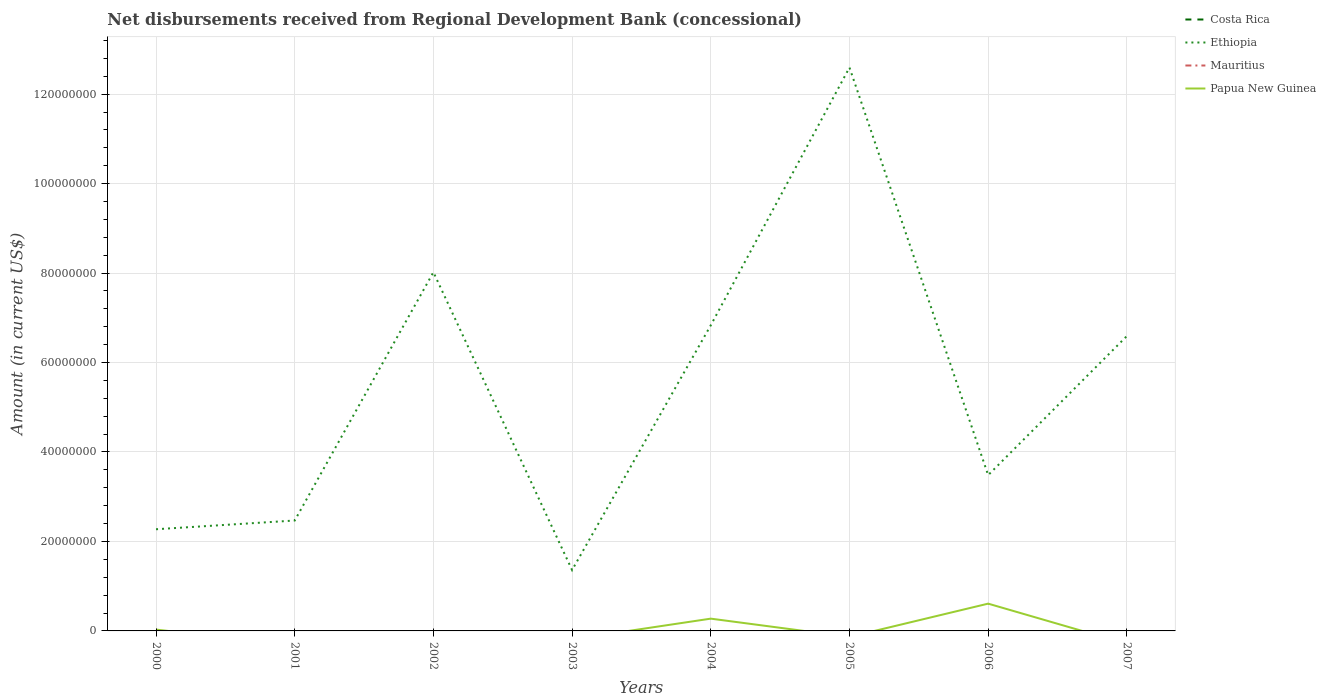Does the line corresponding to Costa Rica intersect with the line corresponding to Papua New Guinea?
Make the answer very short. No. Is the number of lines equal to the number of legend labels?
Your answer should be very brief. No. Across all years, what is the maximum amount of disbursements received from Regional Development Bank in Mauritius?
Offer a terse response. 0. What is the total amount of disbursements received from Regional Development Bank in Ethiopia in the graph?
Your response must be concise. -1.12e+08. What is the difference between the highest and the second highest amount of disbursements received from Regional Development Bank in Papua New Guinea?
Keep it short and to the point. 6.10e+06. Is the amount of disbursements received from Regional Development Bank in Papua New Guinea strictly greater than the amount of disbursements received from Regional Development Bank in Mauritius over the years?
Ensure brevity in your answer.  No. What is the difference between two consecutive major ticks on the Y-axis?
Offer a terse response. 2.00e+07. Are the values on the major ticks of Y-axis written in scientific E-notation?
Ensure brevity in your answer.  No. Where does the legend appear in the graph?
Offer a very short reply. Top right. How many legend labels are there?
Give a very brief answer. 4. What is the title of the graph?
Ensure brevity in your answer.  Net disbursements received from Regional Development Bank (concessional). Does "OECD members" appear as one of the legend labels in the graph?
Offer a terse response. No. What is the label or title of the Y-axis?
Ensure brevity in your answer.  Amount (in current US$). What is the Amount (in current US$) of Costa Rica in 2000?
Offer a terse response. 0. What is the Amount (in current US$) of Ethiopia in 2000?
Offer a very short reply. 2.27e+07. What is the Amount (in current US$) of Mauritius in 2000?
Offer a terse response. 0. What is the Amount (in current US$) in Papua New Guinea in 2000?
Keep it short and to the point. 2.99e+05. What is the Amount (in current US$) in Ethiopia in 2001?
Your answer should be very brief. 2.47e+07. What is the Amount (in current US$) in Papua New Guinea in 2001?
Give a very brief answer. 0. What is the Amount (in current US$) in Costa Rica in 2002?
Keep it short and to the point. 0. What is the Amount (in current US$) in Ethiopia in 2002?
Provide a short and direct response. 8.02e+07. What is the Amount (in current US$) of Ethiopia in 2003?
Ensure brevity in your answer.  1.36e+07. What is the Amount (in current US$) of Papua New Guinea in 2003?
Your response must be concise. 0. What is the Amount (in current US$) of Costa Rica in 2004?
Offer a very short reply. 0. What is the Amount (in current US$) of Ethiopia in 2004?
Offer a very short reply. 6.83e+07. What is the Amount (in current US$) of Papua New Guinea in 2004?
Give a very brief answer. 2.74e+06. What is the Amount (in current US$) of Ethiopia in 2005?
Give a very brief answer. 1.26e+08. What is the Amount (in current US$) in Mauritius in 2005?
Provide a short and direct response. 0. What is the Amount (in current US$) of Ethiopia in 2006?
Make the answer very short. 3.48e+07. What is the Amount (in current US$) in Papua New Guinea in 2006?
Provide a short and direct response. 6.10e+06. What is the Amount (in current US$) in Ethiopia in 2007?
Your answer should be compact. 6.59e+07. What is the Amount (in current US$) of Papua New Guinea in 2007?
Your response must be concise. 0. Across all years, what is the maximum Amount (in current US$) in Ethiopia?
Your response must be concise. 1.26e+08. Across all years, what is the maximum Amount (in current US$) of Papua New Guinea?
Offer a terse response. 6.10e+06. Across all years, what is the minimum Amount (in current US$) of Ethiopia?
Give a very brief answer. 1.36e+07. What is the total Amount (in current US$) in Costa Rica in the graph?
Offer a very short reply. 0. What is the total Amount (in current US$) in Ethiopia in the graph?
Offer a very short reply. 4.36e+08. What is the total Amount (in current US$) of Papua New Guinea in the graph?
Provide a succinct answer. 9.14e+06. What is the difference between the Amount (in current US$) of Ethiopia in 2000 and that in 2001?
Your answer should be compact. -1.95e+06. What is the difference between the Amount (in current US$) of Ethiopia in 2000 and that in 2002?
Offer a very short reply. -5.75e+07. What is the difference between the Amount (in current US$) in Ethiopia in 2000 and that in 2003?
Keep it short and to the point. 9.12e+06. What is the difference between the Amount (in current US$) of Ethiopia in 2000 and that in 2004?
Your answer should be very brief. -4.56e+07. What is the difference between the Amount (in current US$) in Papua New Guinea in 2000 and that in 2004?
Offer a terse response. -2.45e+06. What is the difference between the Amount (in current US$) in Ethiopia in 2000 and that in 2005?
Your answer should be very brief. -1.03e+08. What is the difference between the Amount (in current US$) in Ethiopia in 2000 and that in 2006?
Offer a very short reply. -1.21e+07. What is the difference between the Amount (in current US$) of Papua New Guinea in 2000 and that in 2006?
Your answer should be very brief. -5.80e+06. What is the difference between the Amount (in current US$) of Ethiopia in 2000 and that in 2007?
Give a very brief answer. -4.32e+07. What is the difference between the Amount (in current US$) of Ethiopia in 2001 and that in 2002?
Your response must be concise. -5.55e+07. What is the difference between the Amount (in current US$) in Ethiopia in 2001 and that in 2003?
Provide a succinct answer. 1.11e+07. What is the difference between the Amount (in current US$) of Ethiopia in 2001 and that in 2004?
Your answer should be compact. -4.36e+07. What is the difference between the Amount (in current US$) of Ethiopia in 2001 and that in 2005?
Offer a very short reply. -1.01e+08. What is the difference between the Amount (in current US$) of Ethiopia in 2001 and that in 2006?
Ensure brevity in your answer.  -1.01e+07. What is the difference between the Amount (in current US$) of Ethiopia in 2001 and that in 2007?
Your answer should be compact. -4.12e+07. What is the difference between the Amount (in current US$) of Ethiopia in 2002 and that in 2003?
Your response must be concise. 6.66e+07. What is the difference between the Amount (in current US$) in Ethiopia in 2002 and that in 2004?
Offer a terse response. 1.19e+07. What is the difference between the Amount (in current US$) of Ethiopia in 2002 and that in 2005?
Offer a very short reply. -4.58e+07. What is the difference between the Amount (in current US$) in Ethiopia in 2002 and that in 2006?
Make the answer very short. 4.54e+07. What is the difference between the Amount (in current US$) of Ethiopia in 2002 and that in 2007?
Give a very brief answer. 1.43e+07. What is the difference between the Amount (in current US$) of Ethiopia in 2003 and that in 2004?
Offer a very short reply. -5.47e+07. What is the difference between the Amount (in current US$) of Ethiopia in 2003 and that in 2005?
Provide a short and direct response. -1.12e+08. What is the difference between the Amount (in current US$) in Ethiopia in 2003 and that in 2006?
Make the answer very short. -2.12e+07. What is the difference between the Amount (in current US$) of Ethiopia in 2003 and that in 2007?
Your answer should be compact. -5.23e+07. What is the difference between the Amount (in current US$) of Ethiopia in 2004 and that in 2005?
Offer a terse response. -5.76e+07. What is the difference between the Amount (in current US$) of Ethiopia in 2004 and that in 2006?
Keep it short and to the point. 3.35e+07. What is the difference between the Amount (in current US$) of Papua New Guinea in 2004 and that in 2006?
Give a very brief answer. -3.35e+06. What is the difference between the Amount (in current US$) in Ethiopia in 2004 and that in 2007?
Your response must be concise. 2.41e+06. What is the difference between the Amount (in current US$) in Ethiopia in 2005 and that in 2006?
Give a very brief answer. 9.11e+07. What is the difference between the Amount (in current US$) in Ethiopia in 2005 and that in 2007?
Make the answer very short. 6.00e+07. What is the difference between the Amount (in current US$) of Ethiopia in 2006 and that in 2007?
Ensure brevity in your answer.  -3.11e+07. What is the difference between the Amount (in current US$) in Ethiopia in 2000 and the Amount (in current US$) in Papua New Guinea in 2004?
Your response must be concise. 2.00e+07. What is the difference between the Amount (in current US$) of Ethiopia in 2000 and the Amount (in current US$) of Papua New Guinea in 2006?
Provide a short and direct response. 1.66e+07. What is the difference between the Amount (in current US$) of Ethiopia in 2001 and the Amount (in current US$) of Papua New Guinea in 2004?
Your response must be concise. 2.19e+07. What is the difference between the Amount (in current US$) of Ethiopia in 2001 and the Amount (in current US$) of Papua New Guinea in 2006?
Make the answer very short. 1.86e+07. What is the difference between the Amount (in current US$) of Ethiopia in 2002 and the Amount (in current US$) of Papua New Guinea in 2004?
Give a very brief answer. 7.74e+07. What is the difference between the Amount (in current US$) in Ethiopia in 2002 and the Amount (in current US$) in Papua New Guinea in 2006?
Make the answer very short. 7.41e+07. What is the difference between the Amount (in current US$) in Ethiopia in 2003 and the Amount (in current US$) in Papua New Guinea in 2004?
Give a very brief answer. 1.09e+07. What is the difference between the Amount (in current US$) in Ethiopia in 2003 and the Amount (in current US$) in Papua New Guinea in 2006?
Offer a very short reply. 7.51e+06. What is the difference between the Amount (in current US$) of Ethiopia in 2004 and the Amount (in current US$) of Papua New Guinea in 2006?
Ensure brevity in your answer.  6.22e+07. What is the difference between the Amount (in current US$) in Ethiopia in 2005 and the Amount (in current US$) in Papua New Guinea in 2006?
Your answer should be compact. 1.20e+08. What is the average Amount (in current US$) of Ethiopia per year?
Your answer should be very brief. 5.45e+07. What is the average Amount (in current US$) of Papua New Guinea per year?
Offer a very short reply. 1.14e+06. In the year 2000, what is the difference between the Amount (in current US$) in Ethiopia and Amount (in current US$) in Papua New Guinea?
Make the answer very short. 2.24e+07. In the year 2004, what is the difference between the Amount (in current US$) in Ethiopia and Amount (in current US$) in Papua New Guinea?
Provide a succinct answer. 6.56e+07. In the year 2006, what is the difference between the Amount (in current US$) in Ethiopia and Amount (in current US$) in Papua New Guinea?
Your response must be concise. 2.87e+07. What is the ratio of the Amount (in current US$) in Ethiopia in 2000 to that in 2001?
Your response must be concise. 0.92. What is the ratio of the Amount (in current US$) of Ethiopia in 2000 to that in 2002?
Provide a short and direct response. 0.28. What is the ratio of the Amount (in current US$) in Ethiopia in 2000 to that in 2003?
Offer a very short reply. 1.67. What is the ratio of the Amount (in current US$) in Ethiopia in 2000 to that in 2004?
Ensure brevity in your answer.  0.33. What is the ratio of the Amount (in current US$) in Papua New Guinea in 2000 to that in 2004?
Keep it short and to the point. 0.11. What is the ratio of the Amount (in current US$) in Ethiopia in 2000 to that in 2005?
Offer a very short reply. 0.18. What is the ratio of the Amount (in current US$) in Ethiopia in 2000 to that in 2006?
Make the answer very short. 0.65. What is the ratio of the Amount (in current US$) in Papua New Guinea in 2000 to that in 2006?
Provide a succinct answer. 0.05. What is the ratio of the Amount (in current US$) of Ethiopia in 2000 to that in 2007?
Provide a short and direct response. 0.34. What is the ratio of the Amount (in current US$) in Ethiopia in 2001 to that in 2002?
Give a very brief answer. 0.31. What is the ratio of the Amount (in current US$) in Ethiopia in 2001 to that in 2003?
Provide a short and direct response. 1.81. What is the ratio of the Amount (in current US$) of Ethiopia in 2001 to that in 2004?
Offer a very short reply. 0.36. What is the ratio of the Amount (in current US$) in Ethiopia in 2001 to that in 2005?
Give a very brief answer. 0.2. What is the ratio of the Amount (in current US$) in Ethiopia in 2001 to that in 2006?
Your response must be concise. 0.71. What is the ratio of the Amount (in current US$) in Ethiopia in 2001 to that in 2007?
Give a very brief answer. 0.37. What is the ratio of the Amount (in current US$) in Ethiopia in 2002 to that in 2003?
Offer a terse response. 5.89. What is the ratio of the Amount (in current US$) in Ethiopia in 2002 to that in 2004?
Ensure brevity in your answer.  1.17. What is the ratio of the Amount (in current US$) of Ethiopia in 2002 to that in 2005?
Make the answer very short. 0.64. What is the ratio of the Amount (in current US$) in Ethiopia in 2002 to that in 2006?
Provide a succinct answer. 2.3. What is the ratio of the Amount (in current US$) of Ethiopia in 2002 to that in 2007?
Make the answer very short. 1.22. What is the ratio of the Amount (in current US$) in Ethiopia in 2003 to that in 2004?
Your answer should be very brief. 0.2. What is the ratio of the Amount (in current US$) in Ethiopia in 2003 to that in 2005?
Keep it short and to the point. 0.11. What is the ratio of the Amount (in current US$) in Ethiopia in 2003 to that in 2006?
Make the answer very short. 0.39. What is the ratio of the Amount (in current US$) in Ethiopia in 2003 to that in 2007?
Your answer should be very brief. 0.21. What is the ratio of the Amount (in current US$) in Ethiopia in 2004 to that in 2005?
Your answer should be compact. 0.54. What is the ratio of the Amount (in current US$) of Ethiopia in 2004 to that in 2006?
Give a very brief answer. 1.96. What is the ratio of the Amount (in current US$) in Papua New Guinea in 2004 to that in 2006?
Your response must be concise. 0.45. What is the ratio of the Amount (in current US$) of Ethiopia in 2004 to that in 2007?
Provide a short and direct response. 1.04. What is the ratio of the Amount (in current US$) of Ethiopia in 2005 to that in 2006?
Provide a short and direct response. 3.62. What is the ratio of the Amount (in current US$) of Ethiopia in 2005 to that in 2007?
Ensure brevity in your answer.  1.91. What is the ratio of the Amount (in current US$) of Ethiopia in 2006 to that in 2007?
Your answer should be compact. 0.53. What is the difference between the highest and the second highest Amount (in current US$) of Ethiopia?
Your answer should be compact. 4.58e+07. What is the difference between the highest and the second highest Amount (in current US$) of Papua New Guinea?
Provide a short and direct response. 3.35e+06. What is the difference between the highest and the lowest Amount (in current US$) in Ethiopia?
Your answer should be very brief. 1.12e+08. What is the difference between the highest and the lowest Amount (in current US$) in Papua New Guinea?
Your answer should be very brief. 6.10e+06. 